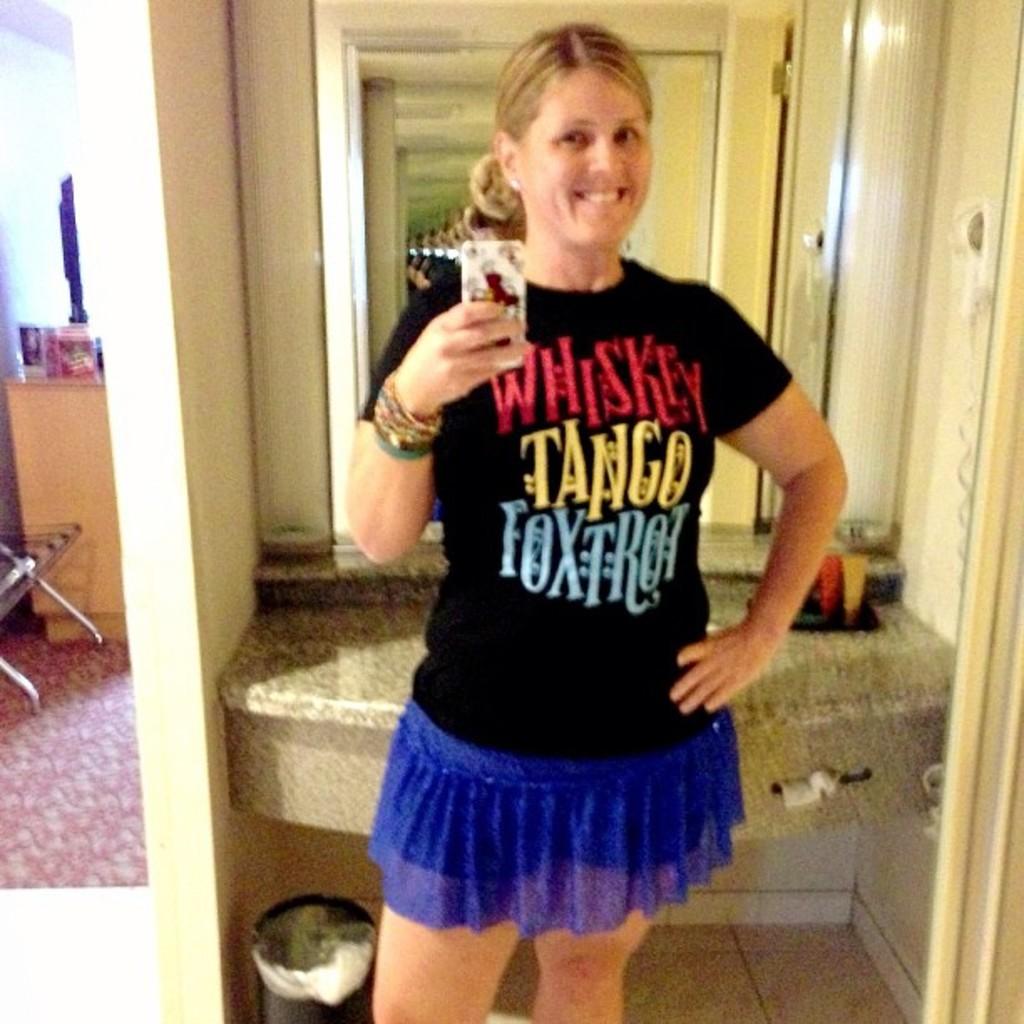What is the word in red letters?
Give a very brief answer. Whiskey. 